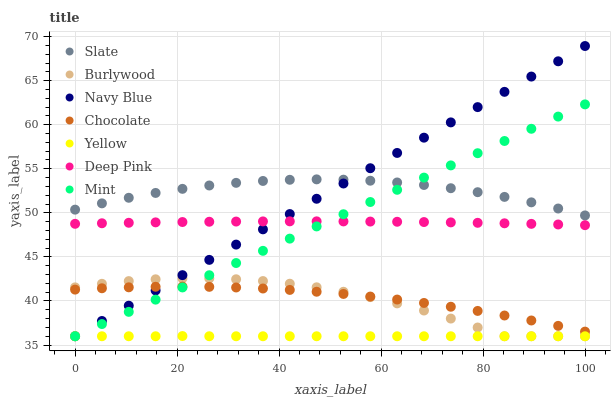Does Yellow have the minimum area under the curve?
Answer yes or no. Yes. Does Slate have the maximum area under the curve?
Answer yes or no. Yes. Does Burlywood have the minimum area under the curve?
Answer yes or no. No. Does Burlywood have the maximum area under the curve?
Answer yes or no. No. Is Mint the smoothest?
Answer yes or no. Yes. Is Burlywood the roughest?
Answer yes or no. Yes. Is Navy Blue the smoothest?
Answer yes or no. No. Is Navy Blue the roughest?
Answer yes or no. No. Does Burlywood have the lowest value?
Answer yes or no. Yes. Does Slate have the lowest value?
Answer yes or no. No. Does Navy Blue have the highest value?
Answer yes or no. Yes. Does Burlywood have the highest value?
Answer yes or no. No. Is Yellow less than Deep Pink?
Answer yes or no. Yes. Is Slate greater than Deep Pink?
Answer yes or no. Yes. Does Mint intersect Yellow?
Answer yes or no. Yes. Is Mint less than Yellow?
Answer yes or no. No. Is Mint greater than Yellow?
Answer yes or no. No. Does Yellow intersect Deep Pink?
Answer yes or no. No. 